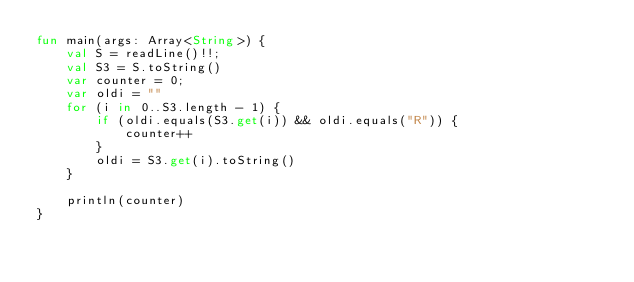<code> <loc_0><loc_0><loc_500><loc_500><_Kotlin_>fun main(args: Array<String>) {
    val S = readLine()!!;
    val S3 = S.toString()
    var counter = 0;
    var oldi = ""
    for (i in 0..S3.length - 1) {
        if (oldi.equals(S3.get(i)) && oldi.equals("R")) {
            counter++
        }
        oldi = S3.get(i).toString()
    }

    println(counter)
}</code> 